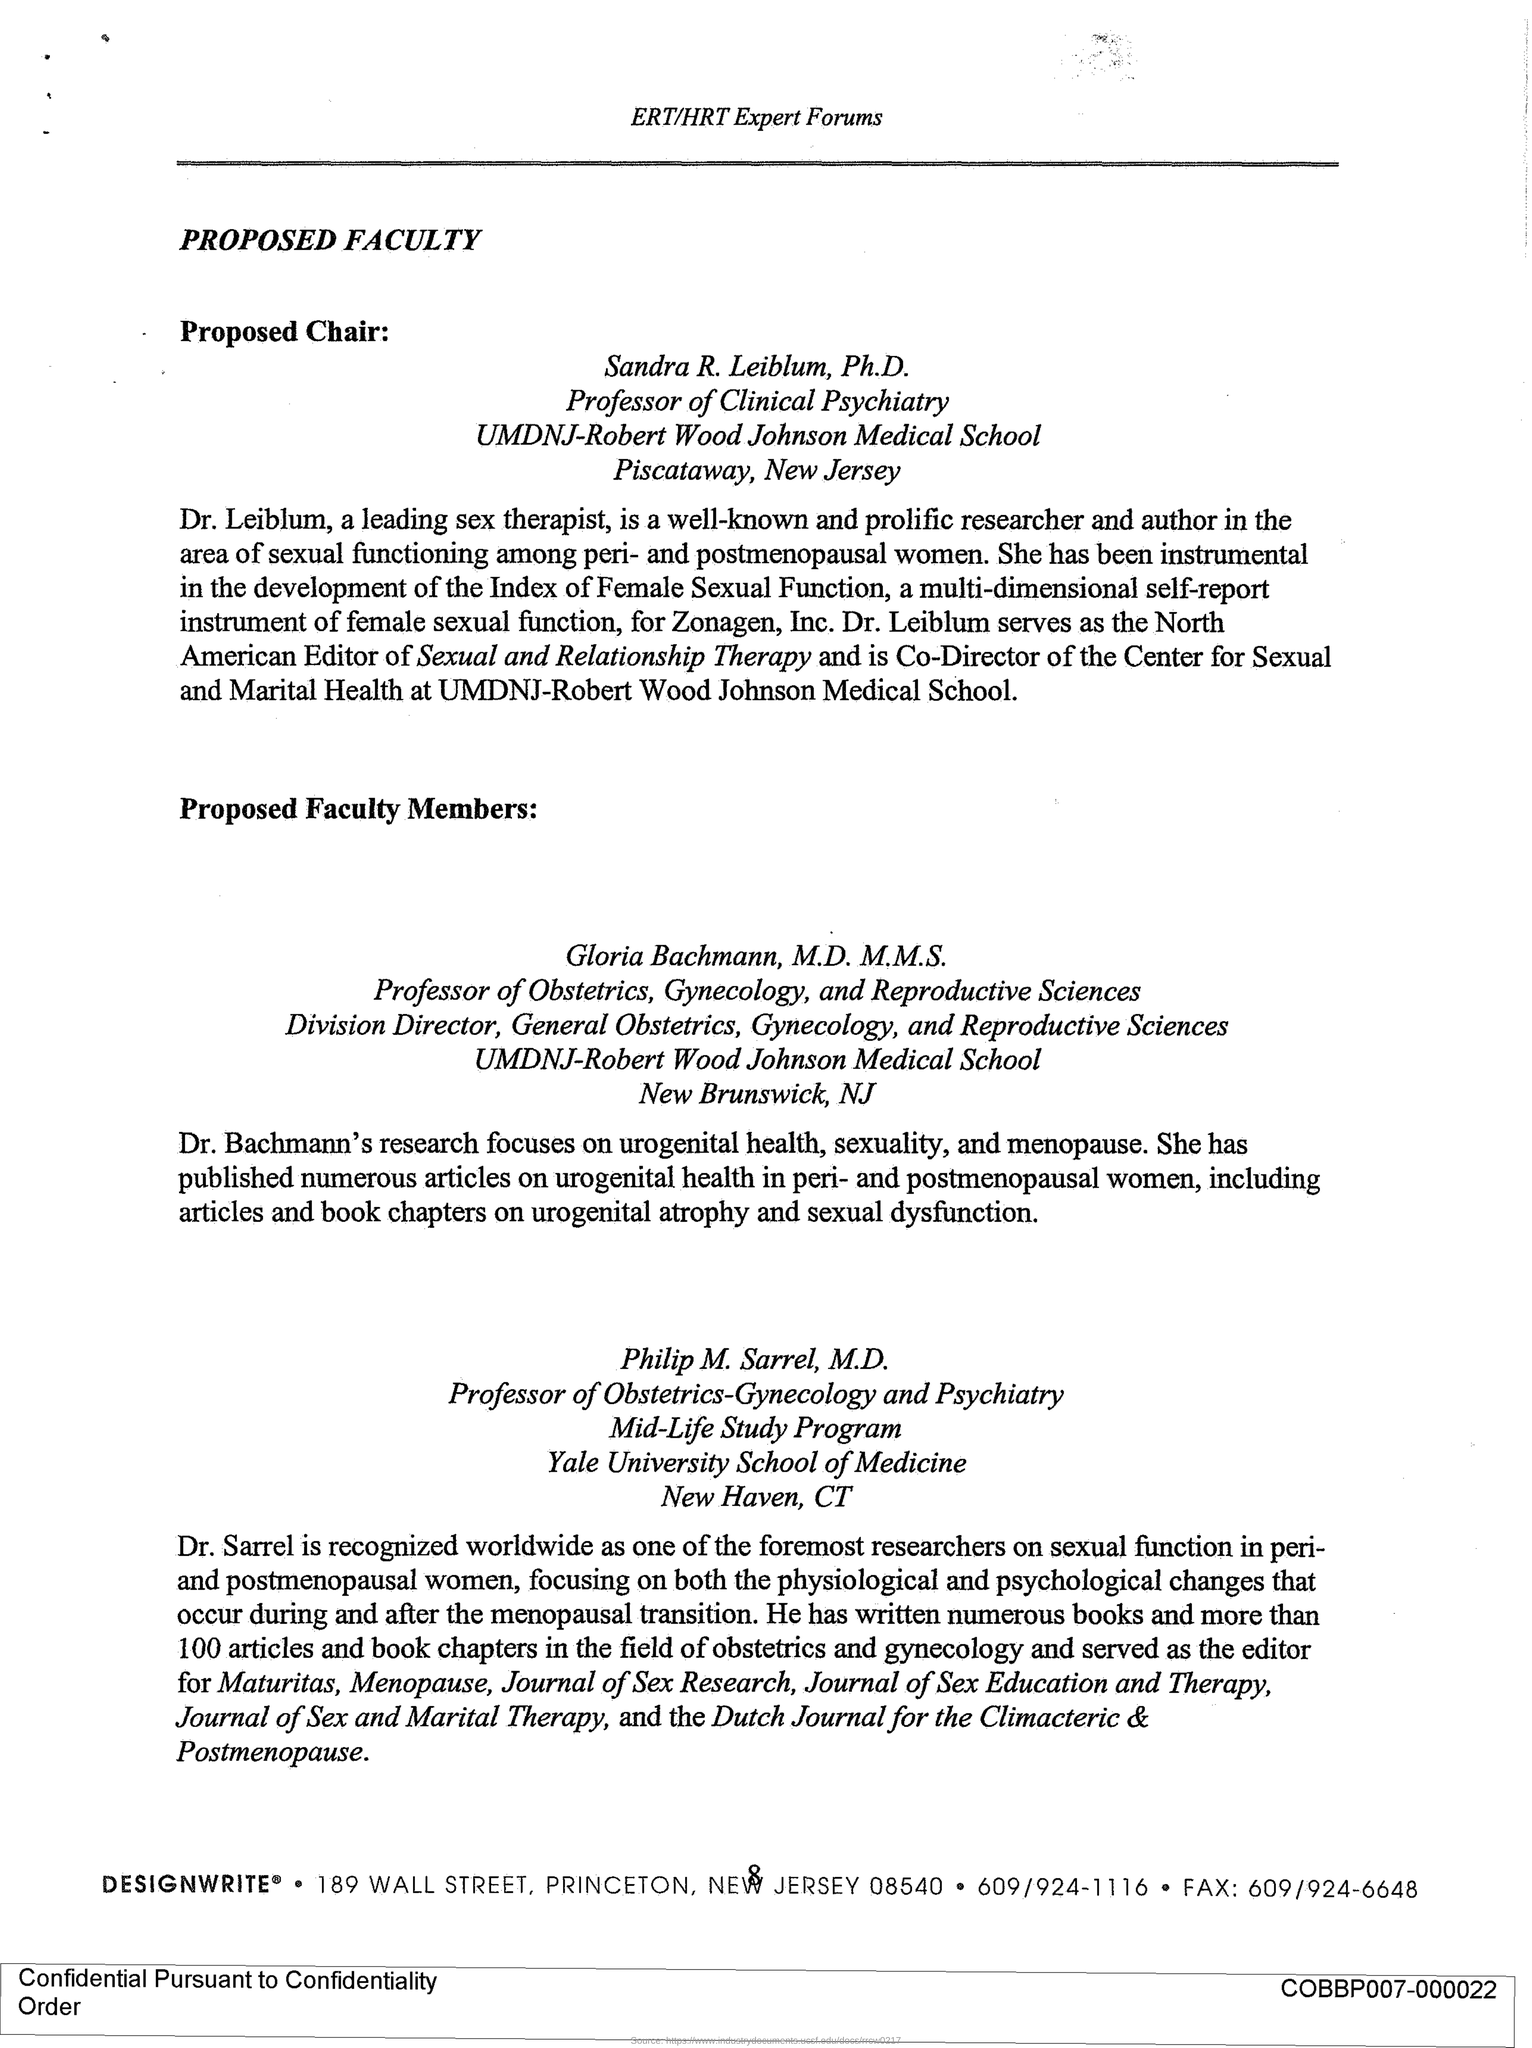What is the Page Number?
Provide a short and direct response. 8. What is the first title in the document?
Offer a very short reply. Proposed Faculty. 